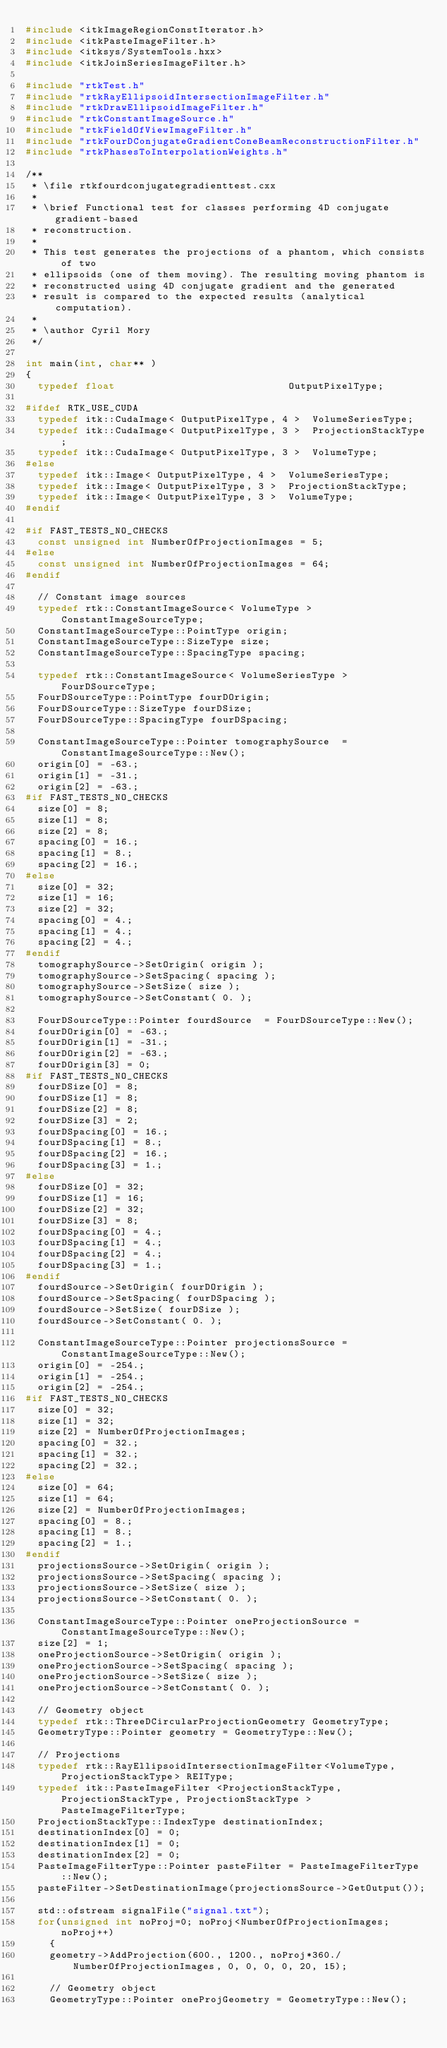Convert code to text. <code><loc_0><loc_0><loc_500><loc_500><_C++_>#include <itkImageRegionConstIterator.h>
#include <itkPasteImageFilter.h>
#include <itksys/SystemTools.hxx>
#include <itkJoinSeriesImageFilter.h>

#include "rtkTest.h"
#include "rtkRayEllipsoidIntersectionImageFilter.h"
#include "rtkDrawEllipsoidImageFilter.h"
#include "rtkConstantImageSource.h"
#include "rtkFieldOfViewImageFilter.h"
#include "rtkFourDConjugateGradientConeBeamReconstructionFilter.h"
#include "rtkPhasesToInterpolationWeights.h"

/**
 * \file rtkfourdconjugategradienttest.cxx
 *
 * \brief Functional test for classes performing 4D conjugate gradient-based
 * reconstruction.
 *
 * This test generates the projections of a phantom, which consists of two
 * ellipsoids (one of them moving). The resulting moving phantom is
 * reconstructed using 4D conjugate gradient and the generated
 * result is compared to the expected results (analytical computation).
 *
 * \author Cyril Mory
 */

int main(int, char** )
{
  typedef float                             OutputPixelType;

#ifdef RTK_USE_CUDA
  typedef itk::CudaImage< OutputPixelType, 4 >  VolumeSeriesType;
  typedef itk::CudaImage< OutputPixelType, 3 >  ProjectionStackType;
  typedef itk::CudaImage< OutputPixelType, 3 >  VolumeType;
#else
  typedef itk::Image< OutputPixelType, 4 >  VolumeSeriesType;
  typedef itk::Image< OutputPixelType, 3 >  ProjectionStackType;
  typedef itk::Image< OutputPixelType, 3 >  VolumeType;
#endif

#if FAST_TESTS_NO_CHECKS
  const unsigned int NumberOfProjectionImages = 5;
#else
  const unsigned int NumberOfProjectionImages = 64;
#endif

  // Constant image sources
  typedef rtk::ConstantImageSource< VolumeType > ConstantImageSourceType;
  ConstantImageSourceType::PointType origin;
  ConstantImageSourceType::SizeType size;
  ConstantImageSourceType::SpacingType spacing;

  typedef rtk::ConstantImageSource< VolumeSeriesType > FourDSourceType;
  FourDSourceType::PointType fourDOrigin;
  FourDSourceType::SizeType fourDSize;
  FourDSourceType::SpacingType fourDSpacing;

  ConstantImageSourceType::Pointer tomographySource  = ConstantImageSourceType::New();
  origin[0] = -63.;
  origin[1] = -31.;
  origin[2] = -63.;
#if FAST_TESTS_NO_CHECKS
  size[0] = 8;
  size[1] = 8;
  size[2] = 8;
  spacing[0] = 16.;
  spacing[1] = 8.;
  spacing[2] = 16.;
#else
  size[0] = 32;
  size[1] = 16;
  size[2] = 32;
  spacing[0] = 4.;
  spacing[1] = 4.;
  spacing[2] = 4.;
#endif
  tomographySource->SetOrigin( origin );
  tomographySource->SetSpacing( spacing );
  tomographySource->SetSize( size );
  tomographySource->SetConstant( 0. );

  FourDSourceType::Pointer fourdSource  = FourDSourceType::New();
  fourDOrigin[0] = -63.;
  fourDOrigin[1] = -31.;
  fourDOrigin[2] = -63.;
  fourDOrigin[3] = 0;
#if FAST_TESTS_NO_CHECKS
  fourDSize[0] = 8;
  fourDSize[1] = 8;
  fourDSize[2] = 8;
  fourDSize[3] = 2;
  fourDSpacing[0] = 16.;
  fourDSpacing[1] = 8.;
  fourDSpacing[2] = 16.;
  fourDSpacing[3] = 1.;
#else
  fourDSize[0] = 32;
  fourDSize[1] = 16;
  fourDSize[2] = 32;
  fourDSize[3] = 8;
  fourDSpacing[0] = 4.;
  fourDSpacing[1] = 4.;
  fourDSpacing[2] = 4.;
  fourDSpacing[3] = 1.;
#endif
  fourdSource->SetOrigin( fourDOrigin );
  fourdSource->SetSpacing( fourDSpacing );
  fourdSource->SetSize( fourDSize );
  fourdSource->SetConstant( 0. );

  ConstantImageSourceType::Pointer projectionsSource = ConstantImageSourceType::New();
  origin[0] = -254.;
  origin[1] = -254.;
  origin[2] = -254.;
#if FAST_TESTS_NO_CHECKS
  size[0] = 32;
  size[1] = 32;
  size[2] = NumberOfProjectionImages;
  spacing[0] = 32.;
  spacing[1] = 32.;
  spacing[2] = 32.;
#else
  size[0] = 64;
  size[1] = 64;
  size[2] = NumberOfProjectionImages;
  spacing[0] = 8.;
  spacing[1] = 8.;
  spacing[2] = 1.;
#endif
  projectionsSource->SetOrigin( origin );
  projectionsSource->SetSpacing( spacing );
  projectionsSource->SetSize( size );
  projectionsSource->SetConstant( 0. );

  ConstantImageSourceType::Pointer oneProjectionSource = ConstantImageSourceType::New();
  size[2] = 1;
  oneProjectionSource->SetOrigin( origin );
  oneProjectionSource->SetSpacing( spacing );
  oneProjectionSource->SetSize( size );
  oneProjectionSource->SetConstant( 0. );

  // Geometry object
  typedef rtk::ThreeDCircularProjectionGeometry GeometryType;
  GeometryType::Pointer geometry = GeometryType::New();

  // Projections
  typedef rtk::RayEllipsoidIntersectionImageFilter<VolumeType, ProjectionStackType> REIType;
  typedef itk::PasteImageFilter <ProjectionStackType, ProjectionStackType, ProjectionStackType > PasteImageFilterType;
  ProjectionStackType::IndexType destinationIndex;
  destinationIndex[0] = 0;
  destinationIndex[1] = 0;
  destinationIndex[2] = 0;
  PasteImageFilterType::Pointer pasteFilter = PasteImageFilterType::New();
  pasteFilter->SetDestinationImage(projectionsSource->GetOutput());

  std::ofstream signalFile("signal.txt");
  for(unsigned int noProj=0; noProj<NumberOfProjectionImages; noProj++)
    {
    geometry->AddProjection(600., 1200., noProj*360./NumberOfProjectionImages, 0, 0, 0, 0, 20, 15);

    // Geometry object
    GeometryType::Pointer oneProjGeometry = GeometryType::New();</code> 